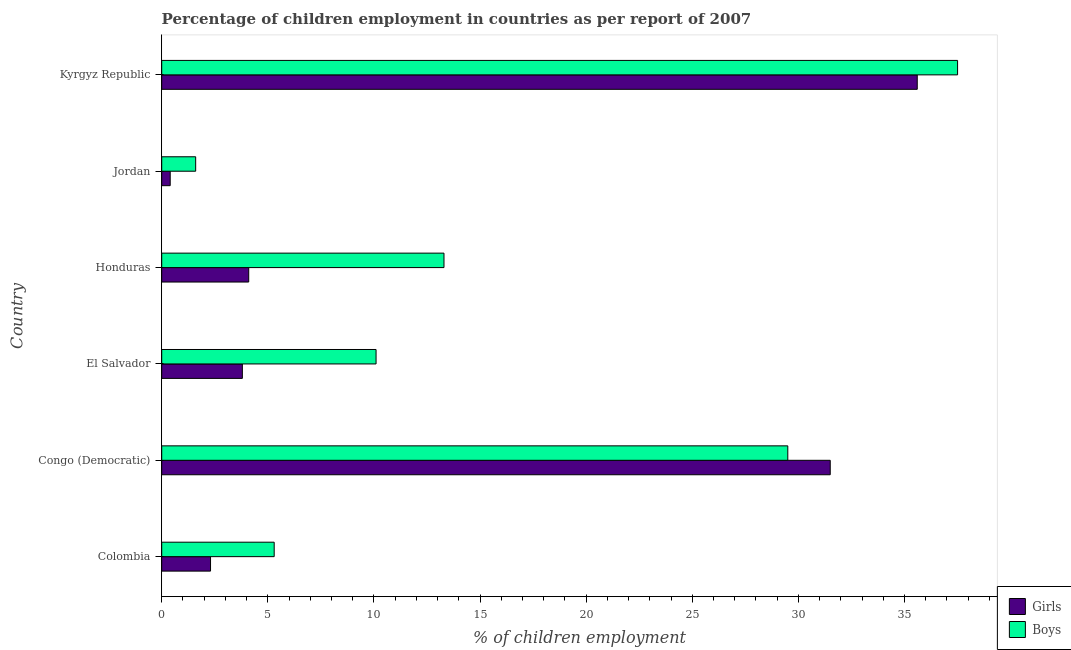How many bars are there on the 2nd tick from the bottom?
Provide a succinct answer. 2. What is the label of the 5th group of bars from the top?
Your answer should be compact. Congo (Democratic). Across all countries, what is the maximum percentage of employed girls?
Make the answer very short. 35.6. Across all countries, what is the minimum percentage of employed girls?
Give a very brief answer. 0.4. In which country was the percentage of employed girls maximum?
Ensure brevity in your answer.  Kyrgyz Republic. In which country was the percentage of employed boys minimum?
Your answer should be very brief. Jordan. What is the total percentage of employed boys in the graph?
Your answer should be compact. 97.3. What is the difference between the percentage of employed boys in Kyrgyz Republic and the percentage of employed girls in Jordan?
Make the answer very short. 37.1. What is the average percentage of employed boys per country?
Your response must be concise. 16.22. What is the difference between the percentage of employed boys and percentage of employed girls in Honduras?
Keep it short and to the point. 9.2. What is the ratio of the percentage of employed girls in El Salvador to that in Kyrgyz Republic?
Keep it short and to the point. 0.11. Is the difference between the percentage of employed girls in Congo (Democratic) and El Salvador greater than the difference between the percentage of employed boys in Congo (Democratic) and El Salvador?
Make the answer very short. Yes. What is the difference between the highest and the lowest percentage of employed boys?
Provide a short and direct response. 35.9. Is the sum of the percentage of employed boys in Congo (Democratic) and El Salvador greater than the maximum percentage of employed girls across all countries?
Offer a terse response. Yes. What does the 2nd bar from the top in Congo (Democratic) represents?
Give a very brief answer. Girls. What does the 1st bar from the bottom in Kyrgyz Republic represents?
Your answer should be very brief. Girls. Are the values on the major ticks of X-axis written in scientific E-notation?
Offer a very short reply. No. Does the graph contain any zero values?
Give a very brief answer. No. Does the graph contain grids?
Your answer should be compact. No. Where does the legend appear in the graph?
Keep it short and to the point. Bottom right. How many legend labels are there?
Offer a very short reply. 2. What is the title of the graph?
Keep it short and to the point. Percentage of children employment in countries as per report of 2007. What is the label or title of the X-axis?
Ensure brevity in your answer.  % of children employment. What is the label or title of the Y-axis?
Offer a terse response. Country. What is the % of children employment of Girls in Colombia?
Give a very brief answer. 2.3. What is the % of children employment of Girls in Congo (Democratic)?
Provide a succinct answer. 31.5. What is the % of children employment of Boys in Congo (Democratic)?
Keep it short and to the point. 29.5. What is the % of children employment of Girls in El Salvador?
Ensure brevity in your answer.  3.8. What is the % of children employment of Boys in El Salvador?
Your answer should be compact. 10.1. What is the % of children employment in Boys in Honduras?
Make the answer very short. 13.3. What is the % of children employment of Boys in Jordan?
Give a very brief answer. 1.6. What is the % of children employment in Girls in Kyrgyz Republic?
Your answer should be very brief. 35.6. What is the % of children employment of Boys in Kyrgyz Republic?
Make the answer very short. 37.5. Across all countries, what is the maximum % of children employment of Girls?
Ensure brevity in your answer.  35.6. Across all countries, what is the maximum % of children employment in Boys?
Give a very brief answer. 37.5. Across all countries, what is the minimum % of children employment of Girls?
Provide a succinct answer. 0.4. Across all countries, what is the minimum % of children employment in Boys?
Your answer should be very brief. 1.6. What is the total % of children employment of Girls in the graph?
Your answer should be very brief. 77.7. What is the total % of children employment of Boys in the graph?
Your answer should be compact. 97.3. What is the difference between the % of children employment in Girls in Colombia and that in Congo (Democratic)?
Your response must be concise. -29.2. What is the difference between the % of children employment in Boys in Colombia and that in Congo (Democratic)?
Your response must be concise. -24.2. What is the difference between the % of children employment of Boys in Colombia and that in El Salvador?
Make the answer very short. -4.8. What is the difference between the % of children employment in Girls in Colombia and that in Honduras?
Keep it short and to the point. -1.8. What is the difference between the % of children employment in Boys in Colombia and that in Honduras?
Ensure brevity in your answer.  -8. What is the difference between the % of children employment of Girls in Colombia and that in Jordan?
Provide a short and direct response. 1.9. What is the difference between the % of children employment in Boys in Colombia and that in Jordan?
Offer a terse response. 3.7. What is the difference between the % of children employment in Girls in Colombia and that in Kyrgyz Republic?
Provide a succinct answer. -33.3. What is the difference between the % of children employment in Boys in Colombia and that in Kyrgyz Republic?
Ensure brevity in your answer.  -32.2. What is the difference between the % of children employment of Girls in Congo (Democratic) and that in El Salvador?
Keep it short and to the point. 27.7. What is the difference between the % of children employment of Boys in Congo (Democratic) and that in El Salvador?
Offer a very short reply. 19.4. What is the difference between the % of children employment in Girls in Congo (Democratic) and that in Honduras?
Your answer should be very brief. 27.4. What is the difference between the % of children employment in Boys in Congo (Democratic) and that in Honduras?
Offer a terse response. 16.2. What is the difference between the % of children employment in Girls in Congo (Democratic) and that in Jordan?
Keep it short and to the point. 31.1. What is the difference between the % of children employment of Boys in Congo (Democratic) and that in Jordan?
Your response must be concise. 27.9. What is the difference between the % of children employment in Girls in El Salvador and that in Honduras?
Provide a succinct answer. -0.3. What is the difference between the % of children employment of Girls in El Salvador and that in Kyrgyz Republic?
Your answer should be compact. -31.8. What is the difference between the % of children employment of Boys in El Salvador and that in Kyrgyz Republic?
Your answer should be compact. -27.4. What is the difference between the % of children employment in Girls in Honduras and that in Kyrgyz Republic?
Make the answer very short. -31.5. What is the difference between the % of children employment in Boys in Honduras and that in Kyrgyz Republic?
Make the answer very short. -24.2. What is the difference between the % of children employment in Girls in Jordan and that in Kyrgyz Republic?
Make the answer very short. -35.2. What is the difference between the % of children employment of Boys in Jordan and that in Kyrgyz Republic?
Give a very brief answer. -35.9. What is the difference between the % of children employment in Girls in Colombia and the % of children employment in Boys in Congo (Democratic)?
Your response must be concise. -27.2. What is the difference between the % of children employment in Girls in Colombia and the % of children employment in Boys in El Salvador?
Offer a terse response. -7.8. What is the difference between the % of children employment of Girls in Colombia and the % of children employment of Boys in Kyrgyz Republic?
Keep it short and to the point. -35.2. What is the difference between the % of children employment of Girls in Congo (Democratic) and the % of children employment of Boys in El Salvador?
Offer a terse response. 21.4. What is the difference between the % of children employment of Girls in Congo (Democratic) and the % of children employment of Boys in Jordan?
Your answer should be compact. 29.9. What is the difference between the % of children employment in Girls in Congo (Democratic) and the % of children employment in Boys in Kyrgyz Republic?
Ensure brevity in your answer.  -6. What is the difference between the % of children employment of Girls in El Salvador and the % of children employment of Boys in Kyrgyz Republic?
Ensure brevity in your answer.  -33.7. What is the difference between the % of children employment of Girls in Honduras and the % of children employment of Boys in Jordan?
Give a very brief answer. 2.5. What is the difference between the % of children employment in Girls in Honduras and the % of children employment in Boys in Kyrgyz Republic?
Your answer should be compact. -33.4. What is the difference between the % of children employment in Girls in Jordan and the % of children employment in Boys in Kyrgyz Republic?
Provide a short and direct response. -37.1. What is the average % of children employment of Girls per country?
Provide a short and direct response. 12.95. What is the average % of children employment in Boys per country?
Provide a short and direct response. 16.22. What is the difference between the % of children employment in Girls and % of children employment in Boys in Congo (Democratic)?
Offer a terse response. 2. What is the difference between the % of children employment in Girls and % of children employment in Boys in Honduras?
Make the answer very short. -9.2. What is the difference between the % of children employment in Girls and % of children employment in Boys in Jordan?
Your answer should be compact. -1.2. What is the ratio of the % of children employment of Girls in Colombia to that in Congo (Democratic)?
Give a very brief answer. 0.07. What is the ratio of the % of children employment in Boys in Colombia to that in Congo (Democratic)?
Keep it short and to the point. 0.18. What is the ratio of the % of children employment of Girls in Colombia to that in El Salvador?
Provide a succinct answer. 0.61. What is the ratio of the % of children employment in Boys in Colombia to that in El Salvador?
Make the answer very short. 0.52. What is the ratio of the % of children employment of Girls in Colombia to that in Honduras?
Provide a short and direct response. 0.56. What is the ratio of the % of children employment in Boys in Colombia to that in Honduras?
Give a very brief answer. 0.4. What is the ratio of the % of children employment of Girls in Colombia to that in Jordan?
Your answer should be very brief. 5.75. What is the ratio of the % of children employment in Boys in Colombia to that in Jordan?
Give a very brief answer. 3.31. What is the ratio of the % of children employment of Girls in Colombia to that in Kyrgyz Republic?
Keep it short and to the point. 0.06. What is the ratio of the % of children employment of Boys in Colombia to that in Kyrgyz Republic?
Make the answer very short. 0.14. What is the ratio of the % of children employment in Girls in Congo (Democratic) to that in El Salvador?
Ensure brevity in your answer.  8.29. What is the ratio of the % of children employment in Boys in Congo (Democratic) to that in El Salvador?
Ensure brevity in your answer.  2.92. What is the ratio of the % of children employment in Girls in Congo (Democratic) to that in Honduras?
Make the answer very short. 7.68. What is the ratio of the % of children employment in Boys in Congo (Democratic) to that in Honduras?
Your answer should be very brief. 2.22. What is the ratio of the % of children employment of Girls in Congo (Democratic) to that in Jordan?
Give a very brief answer. 78.75. What is the ratio of the % of children employment of Boys in Congo (Democratic) to that in Jordan?
Offer a terse response. 18.44. What is the ratio of the % of children employment in Girls in Congo (Democratic) to that in Kyrgyz Republic?
Your answer should be compact. 0.88. What is the ratio of the % of children employment of Boys in Congo (Democratic) to that in Kyrgyz Republic?
Your answer should be very brief. 0.79. What is the ratio of the % of children employment in Girls in El Salvador to that in Honduras?
Give a very brief answer. 0.93. What is the ratio of the % of children employment of Boys in El Salvador to that in Honduras?
Give a very brief answer. 0.76. What is the ratio of the % of children employment of Boys in El Salvador to that in Jordan?
Ensure brevity in your answer.  6.31. What is the ratio of the % of children employment of Girls in El Salvador to that in Kyrgyz Republic?
Your response must be concise. 0.11. What is the ratio of the % of children employment of Boys in El Salvador to that in Kyrgyz Republic?
Make the answer very short. 0.27. What is the ratio of the % of children employment in Girls in Honduras to that in Jordan?
Your response must be concise. 10.25. What is the ratio of the % of children employment in Boys in Honduras to that in Jordan?
Your response must be concise. 8.31. What is the ratio of the % of children employment in Girls in Honduras to that in Kyrgyz Republic?
Offer a terse response. 0.12. What is the ratio of the % of children employment in Boys in Honduras to that in Kyrgyz Republic?
Keep it short and to the point. 0.35. What is the ratio of the % of children employment of Girls in Jordan to that in Kyrgyz Republic?
Ensure brevity in your answer.  0.01. What is the ratio of the % of children employment in Boys in Jordan to that in Kyrgyz Republic?
Provide a short and direct response. 0.04. What is the difference between the highest and the lowest % of children employment of Girls?
Give a very brief answer. 35.2. What is the difference between the highest and the lowest % of children employment of Boys?
Give a very brief answer. 35.9. 